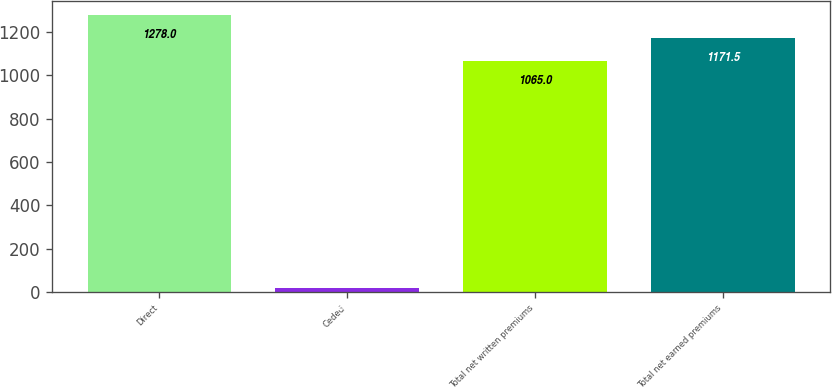Convert chart to OTSL. <chart><loc_0><loc_0><loc_500><loc_500><bar_chart><fcel>Direct<fcel>Ceded<fcel>Total net written premiums<fcel>Total net earned premiums<nl><fcel>1278<fcel>20<fcel>1065<fcel>1171.5<nl></chart> 